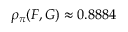Convert formula to latex. <formula><loc_0><loc_0><loc_500><loc_500>\rho _ { \pi } ( F , G ) \approx 0 . 8 8 8 4</formula> 